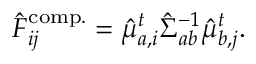<formula> <loc_0><loc_0><loc_500><loc_500>\begin{array} { r } { \hat { F } _ { i j } ^ { c o m p . } = \hat { \mu } _ { a , i } ^ { t } { \hat { \Sigma } } _ { a b } ^ { - 1 } \hat { \mu } _ { b , j } ^ { t } . } \end{array}</formula> 